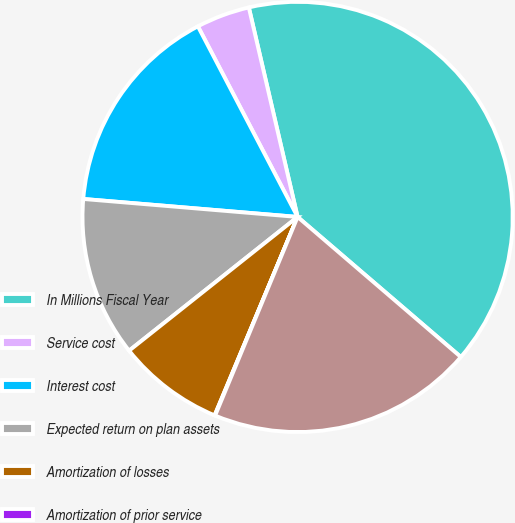Convert chart. <chart><loc_0><loc_0><loc_500><loc_500><pie_chart><fcel>In Millions Fiscal Year<fcel>Service cost<fcel>Interest cost<fcel>Expected return on plan assets<fcel>Amortization of losses<fcel>Amortization of prior service<fcel>Net periodic benefit (income)<nl><fcel>39.93%<fcel>4.03%<fcel>16.0%<fcel>12.01%<fcel>8.02%<fcel>0.04%<fcel>19.98%<nl></chart> 